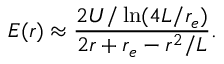Convert formula to latex. <formula><loc_0><loc_0><loc_500><loc_500>E ( r ) \approx \frac { 2 U / \ln ( 4 L / r _ { e } ) } { 2 r + r _ { e } - r ^ { 2 } / L } .</formula> 